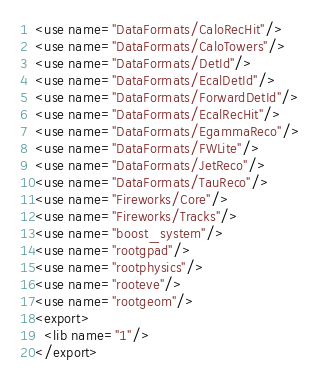Convert code to text. <code><loc_0><loc_0><loc_500><loc_500><_XML_><use name="DataFormats/CaloRecHit"/>
<use name="DataFormats/CaloTowers"/>
<use name="DataFormats/DetId"/>
<use name="DataFormats/EcalDetId"/>
<use name="DataFormats/ForwardDetId"/>
<use name="DataFormats/EcalRecHit"/>
<use name="DataFormats/EgammaReco"/>
<use name="DataFormats/FWLite"/>
<use name="DataFormats/JetReco"/>
<use name="DataFormats/TauReco"/>
<use name="Fireworks/Core"/>
<use name="Fireworks/Tracks"/>
<use name="boost_system"/>
<use name="rootgpad"/>
<use name="rootphysics"/>
<use name="rooteve"/>
<use name="rootgeom"/>
<export>
  <lib name="1"/>
</export>
</code> 